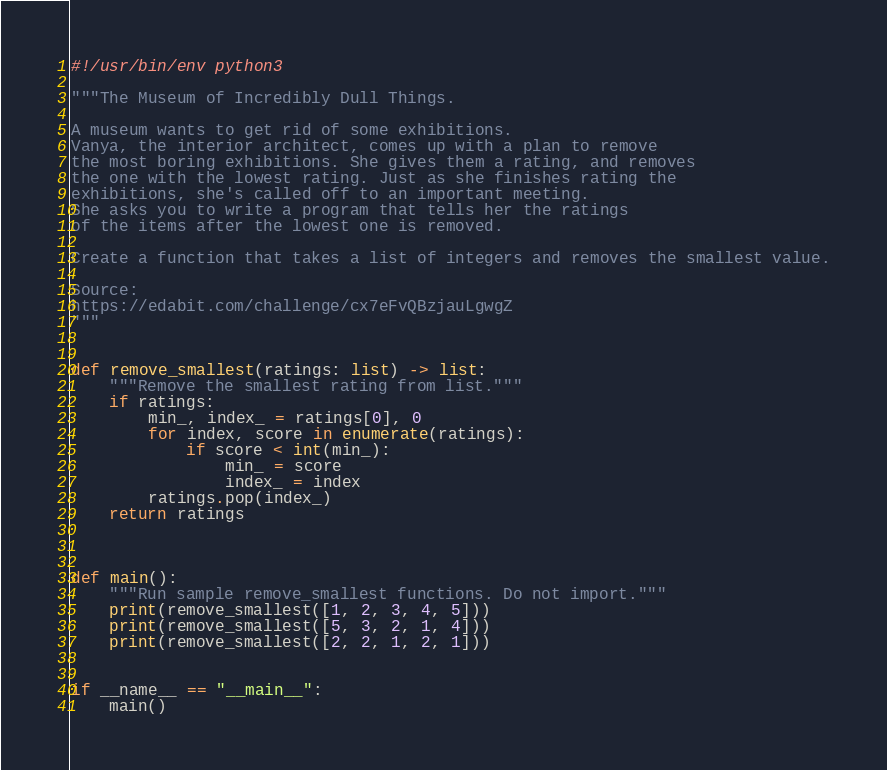Convert code to text. <code><loc_0><loc_0><loc_500><loc_500><_Python_>#!/usr/bin/env python3

"""The Museum of Incredibly Dull Things.

A museum wants to get rid of some exhibitions.
Vanya, the interior architect, comes up with a plan to remove
the most boring exhibitions. She gives them a rating, and removes
the one with the lowest rating. Just as she finishes rating the
exhibitions, she's called off to an important meeting.
She asks you to write a program that tells her the ratings
of the items after the lowest one is removed.

Create a function that takes a list of integers and removes the smallest value.

Source:
https://edabit.com/challenge/cx7eFvQBzjauLgwgZ
"""


def remove_smallest(ratings: list) -> list:
    """Remove the smallest rating from list."""
    if ratings:
        min_, index_ = ratings[0], 0
        for index, score in enumerate(ratings):
            if score < int(min_):
                min_ = score
                index_ = index
        ratings.pop(index_)
    return ratings
    


def main():
    """Run sample remove_smallest functions. Do not import."""
    print(remove_smallest([1, 2, 3, 4, 5]))
    print(remove_smallest([5, 3, 2, 1, 4]))
    print(remove_smallest([2, 2, 1, 2, 1]))


if __name__ == "__main__":
    main()
</code> 